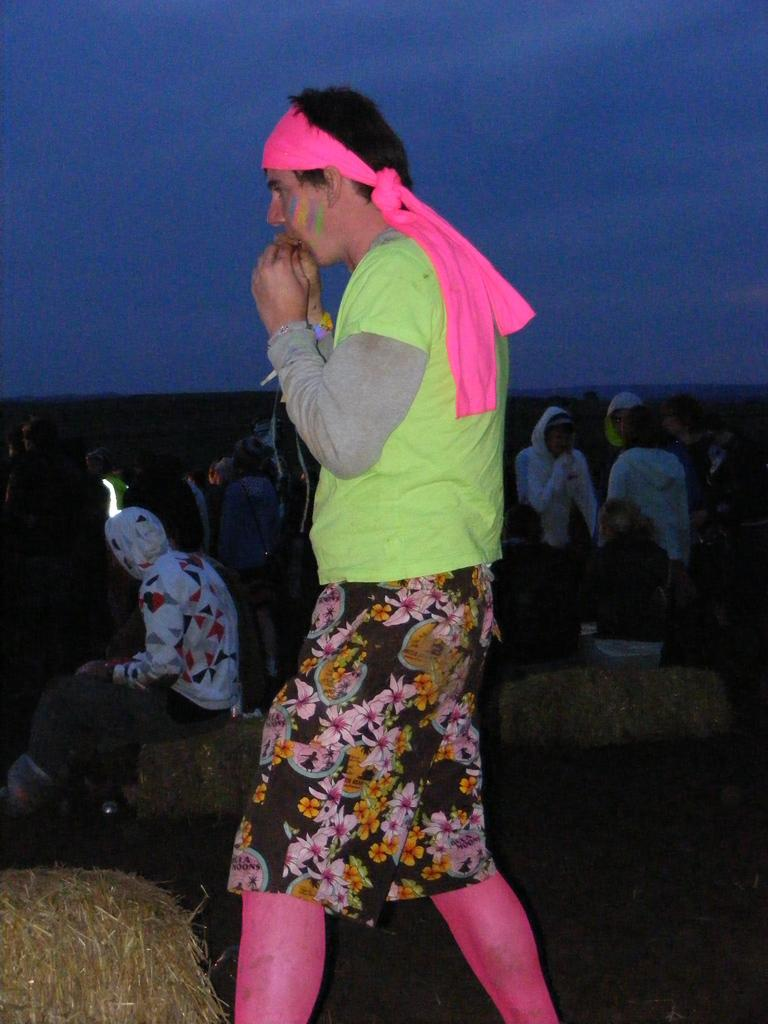Who or what is present in the image? There are people in the image. What are the people wearing? The people are wearing clothes. What can be seen at the top of the image? The sky is visible at the top of the image. How many tickets are being held by the people in the image? There is no mention of tickets in the image, so it cannot be determined how many, if any, are being held. 